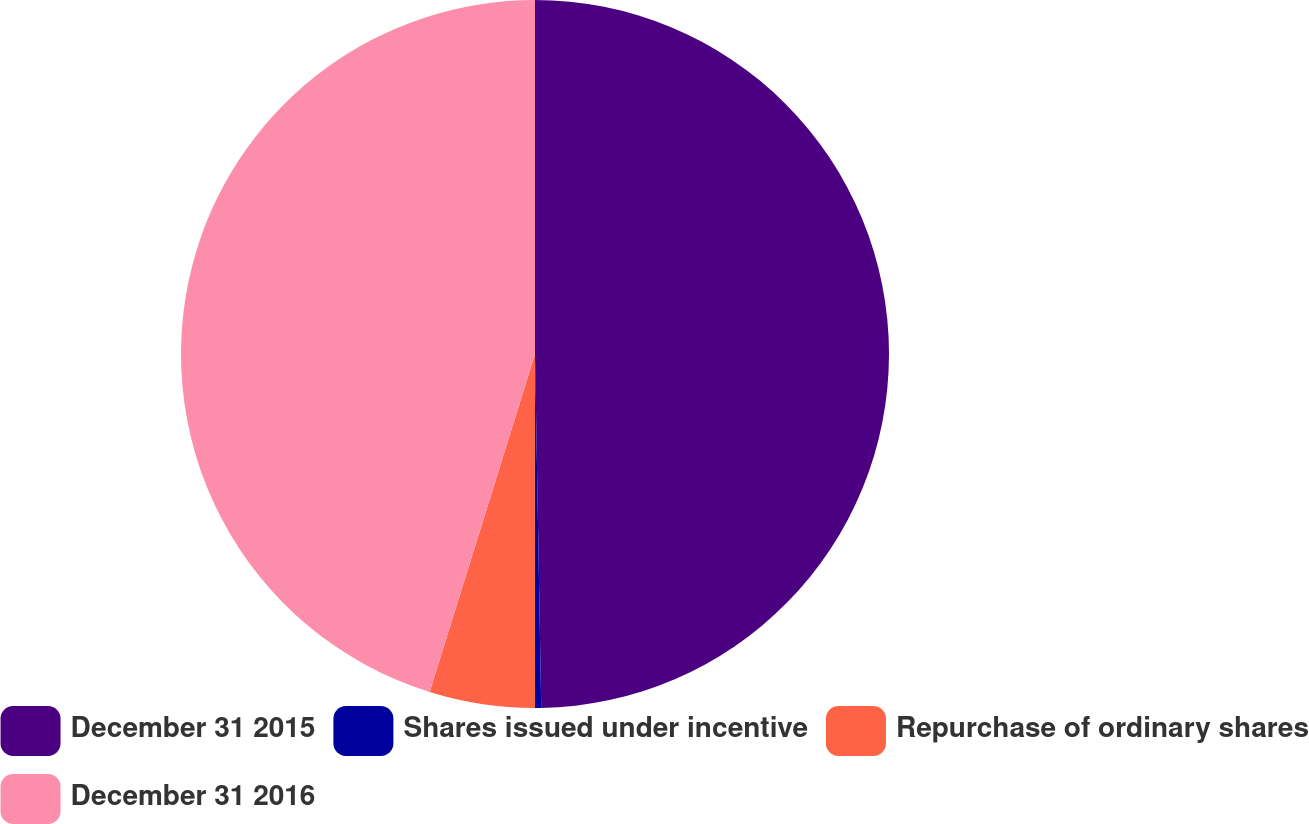<chart> <loc_0><loc_0><loc_500><loc_500><pie_chart><fcel>December 31 2015<fcel>Shares issued under incentive<fcel>Repurchase of ordinary shares<fcel>December 31 2016<nl><fcel>49.72%<fcel>0.28%<fcel>4.81%<fcel>45.19%<nl></chart> 